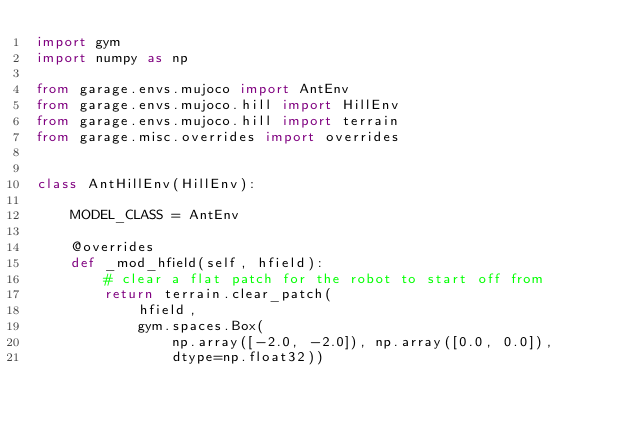Convert code to text. <code><loc_0><loc_0><loc_500><loc_500><_Python_>import gym
import numpy as np

from garage.envs.mujoco import AntEnv
from garage.envs.mujoco.hill import HillEnv
from garage.envs.mujoco.hill import terrain
from garage.misc.overrides import overrides


class AntHillEnv(HillEnv):

    MODEL_CLASS = AntEnv

    @overrides
    def _mod_hfield(self, hfield):
        # clear a flat patch for the robot to start off from
        return terrain.clear_patch(
            hfield,
            gym.spaces.Box(
                np.array([-2.0, -2.0]), np.array([0.0, 0.0]),
                dtype=np.float32))
</code> 